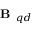<formula> <loc_0><loc_0><loc_500><loc_500>B _ { q d }</formula> 